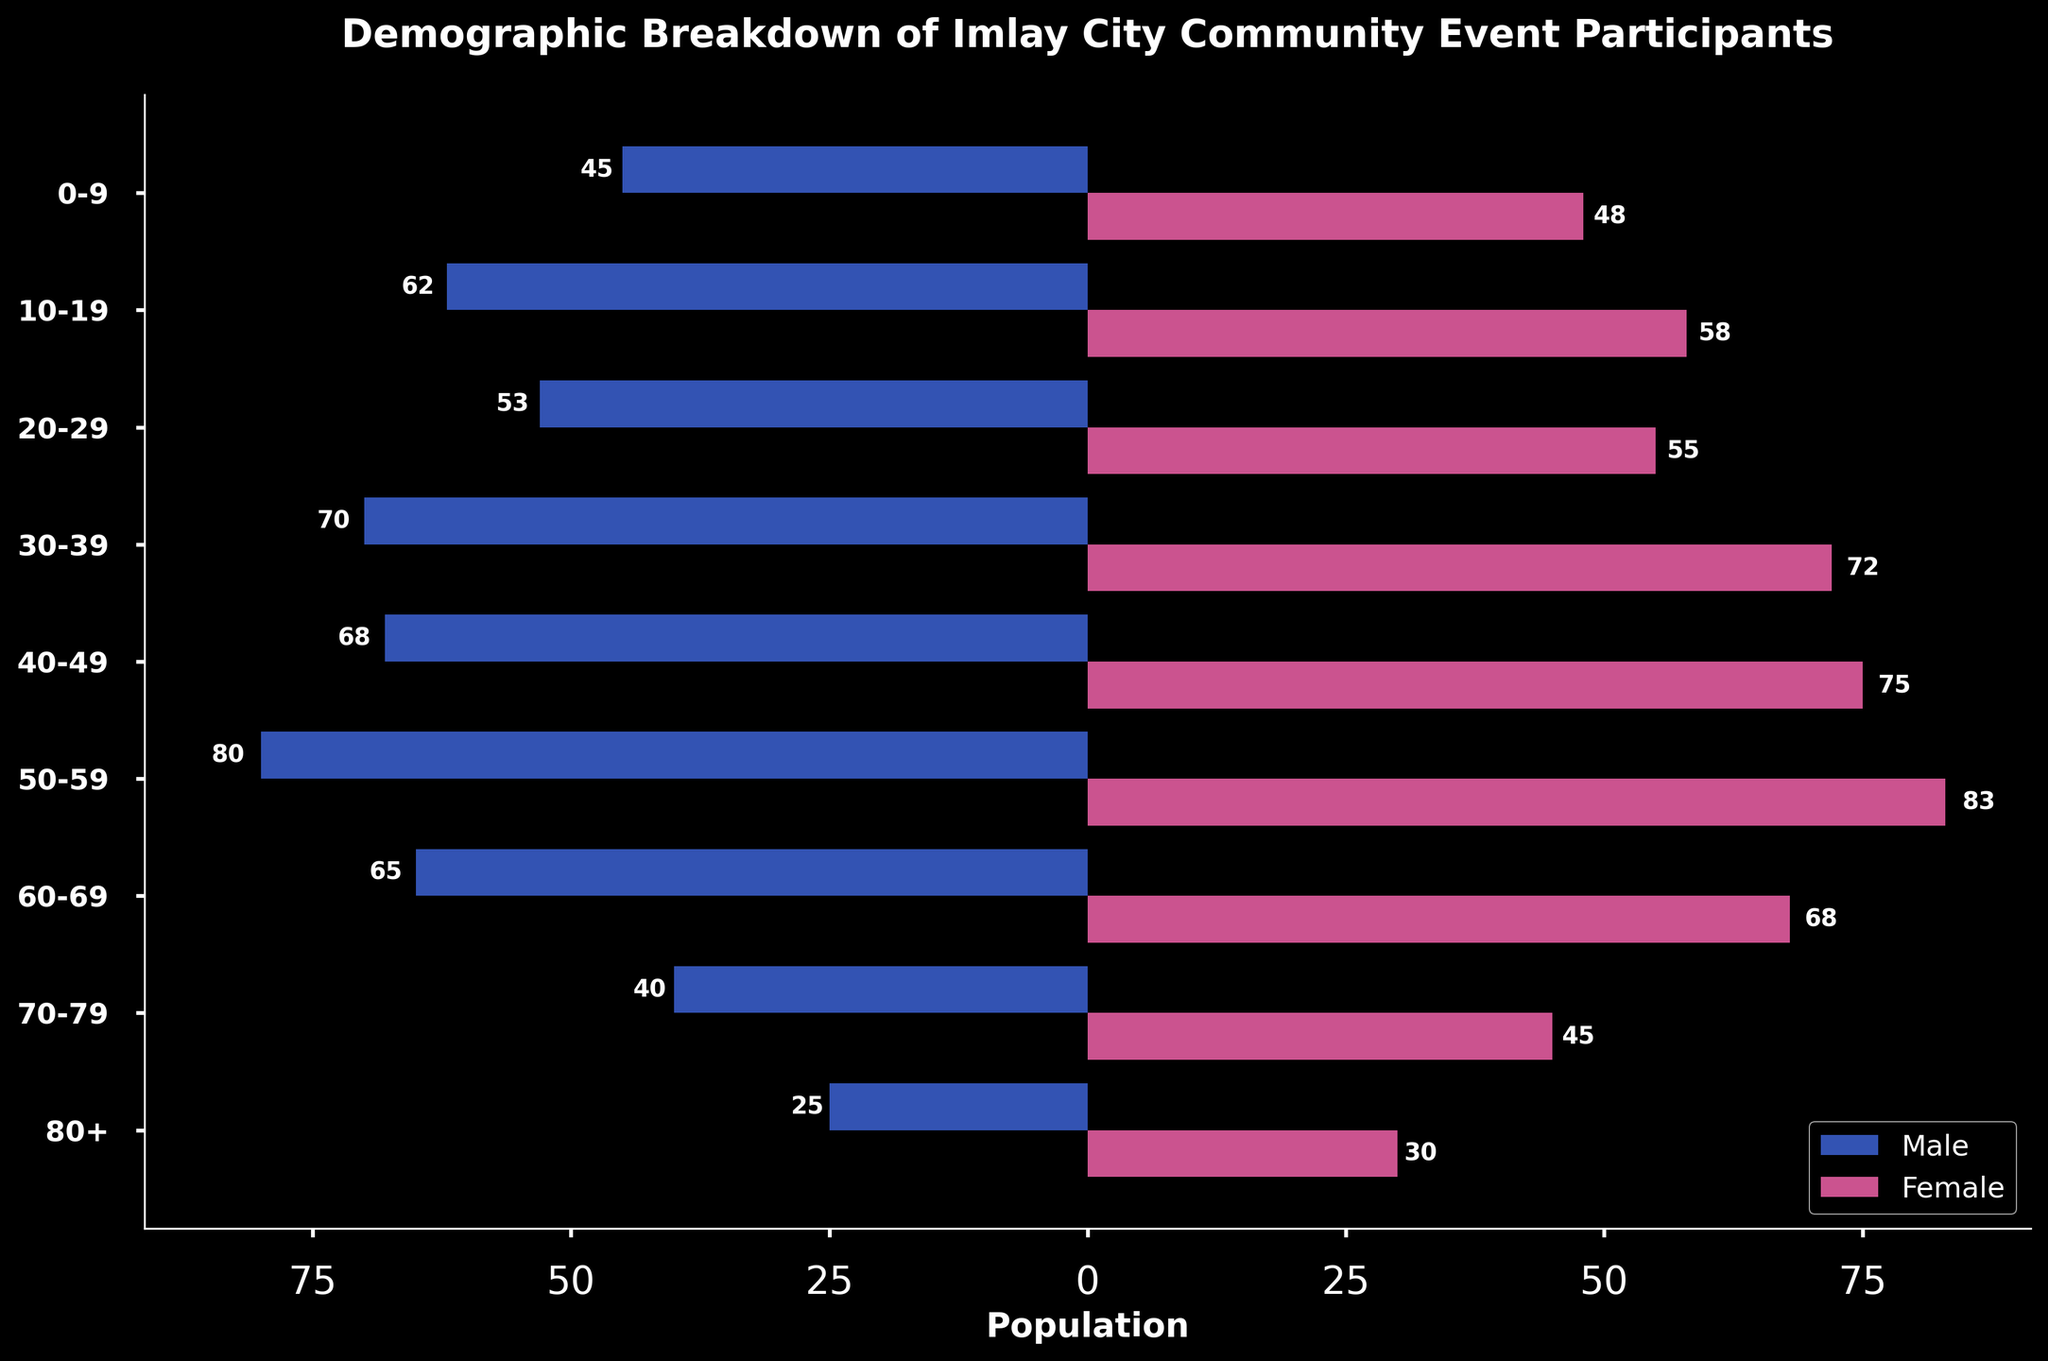What's the title of the figure? The title can be found at the top of the figure. It reads "Demographic Breakdown of Imlay City Community Event Participants".
Answer: Demographic Breakdown of Imlay City Community Event Participants What does each color bar represent? The colors of the bars correspond to different genders. The blue bars (left side) represent males, and the pink bars (right side) represent females. This can be deduced from the legend at the bottom-right corner of the figure.
Answer: Blue for males, pink for females Which age group has the largest number of female participants? To find this, look for the pink bar that extends the furthest to the right. The age group with the longest pink bar is 50-59, where the number reaches 83.
Answer: 50-59 What are the age groups with more male participants than female participants? Compare the lengths of the blue bars (left) and pink bars (right) for each age group. The age groups where the blue bar is longer are 0-9, 10-19, and 60-69.
Answer: 0-9, 10-19, 60-69 How many male participants are there in the 30-39 age group? The value can be read directly from the left (blue) bar of the 30-39 age group, which is labeled as 70.
Answer: 70 What is the total number of participants for the 40-49 age group? Sum the number of male and female participants in this age group. The left (blue) bar shows 68 males, and the right (pink) bar shows 75 females. Therefore, the total is 68 + 75 = 143.
Answer: 143 Which age group has the smallest number of participants overall? To find this, compare the total lengths of both the blue and pink bars combined for each age group. The age group 80+ has 25 males and 30 females, totaling 55, which is the smallest overall number.
Answer: 80+ What is the difference in the number of participants between the 50-59 and 70-79 age groups? Calculate the total number of participants in each age group first (50-59: 80 males + 83 females = 163, 70-79: 40 males + 45 females = 85). The difference is 163 - 85 = 78.
Answer: 78 What is the average number of participants per gender in the 30-39 age group? First, find the sum of male and female participants in the 30-39 age group: 70 (males) + 72 (females) = 142 participants. Then, divide by 2 to get the average: 142 / 2 = 71.
Answer: 71 